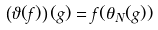<formula> <loc_0><loc_0><loc_500><loc_500>\left ( \vartheta ( f ) \right ) ( g ) = f ( \theta _ { N } ( g ) )</formula> 